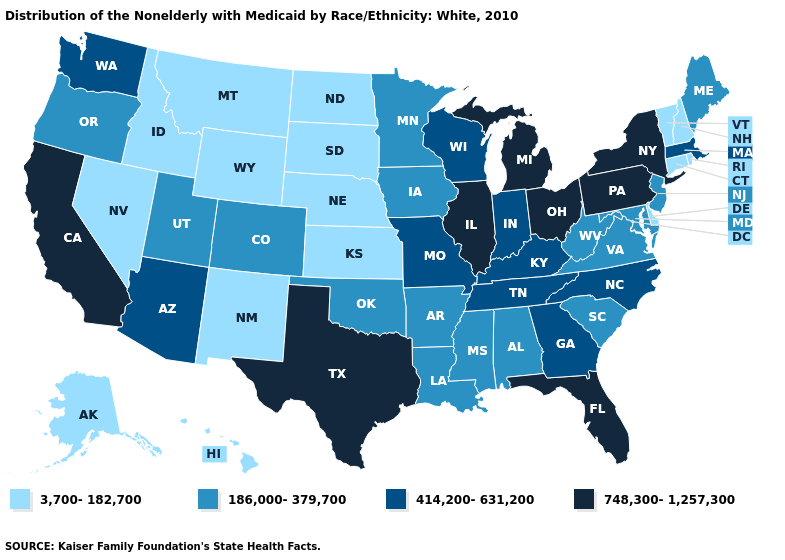Is the legend a continuous bar?
Concise answer only. No. Among the states that border West Virginia , which have the highest value?
Answer briefly. Ohio, Pennsylvania. What is the value of South Dakota?
Keep it brief. 3,700-182,700. Name the states that have a value in the range 3,700-182,700?
Be succinct. Alaska, Connecticut, Delaware, Hawaii, Idaho, Kansas, Montana, Nebraska, Nevada, New Hampshire, New Mexico, North Dakota, Rhode Island, South Dakota, Vermont, Wyoming. Does the first symbol in the legend represent the smallest category?
Write a very short answer. Yes. Does Florida have the highest value in the South?
Answer briefly. Yes. Name the states that have a value in the range 414,200-631,200?
Short answer required. Arizona, Georgia, Indiana, Kentucky, Massachusetts, Missouri, North Carolina, Tennessee, Washington, Wisconsin. Does Texas have the highest value in the USA?
Short answer required. Yes. What is the highest value in the MidWest ?
Give a very brief answer. 748,300-1,257,300. Name the states that have a value in the range 186,000-379,700?
Give a very brief answer. Alabama, Arkansas, Colorado, Iowa, Louisiana, Maine, Maryland, Minnesota, Mississippi, New Jersey, Oklahoma, Oregon, South Carolina, Utah, Virginia, West Virginia. What is the lowest value in the Northeast?
Quick response, please. 3,700-182,700. Among the states that border Idaho , which have the lowest value?
Short answer required. Montana, Nevada, Wyoming. Name the states that have a value in the range 748,300-1,257,300?
Keep it brief. California, Florida, Illinois, Michigan, New York, Ohio, Pennsylvania, Texas. Name the states that have a value in the range 186,000-379,700?
Write a very short answer. Alabama, Arkansas, Colorado, Iowa, Louisiana, Maine, Maryland, Minnesota, Mississippi, New Jersey, Oklahoma, Oregon, South Carolina, Utah, Virginia, West Virginia. Does California have the lowest value in the USA?
Keep it brief. No. 